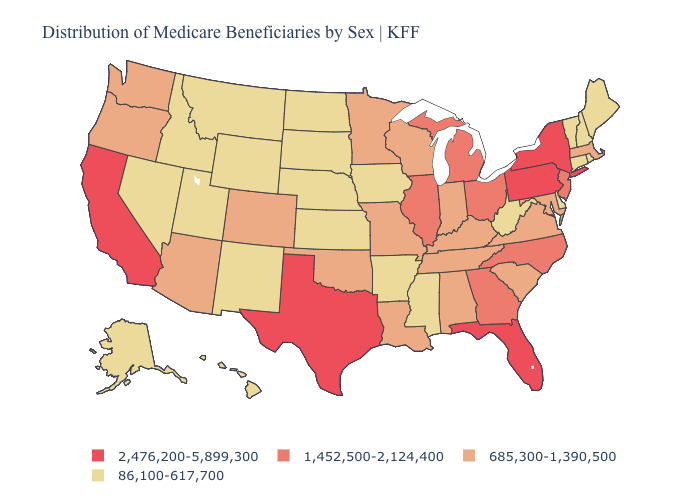Which states hav the highest value in the Northeast?
Concise answer only. New York, Pennsylvania. What is the value of Michigan?
Be succinct. 1,452,500-2,124,400. What is the highest value in the USA?
Answer briefly. 2,476,200-5,899,300. Does Hawaii have the lowest value in the USA?
Quick response, please. Yes. Among the states that border Louisiana , does Arkansas have the highest value?
Write a very short answer. No. Name the states that have a value in the range 1,452,500-2,124,400?
Keep it brief. Georgia, Illinois, Michigan, New Jersey, North Carolina, Ohio. Does New York have the highest value in the USA?
Short answer required. Yes. Name the states that have a value in the range 2,476,200-5,899,300?
Quick response, please. California, Florida, New York, Pennsylvania, Texas. Does the map have missing data?
Write a very short answer. No. What is the value of Rhode Island?
Give a very brief answer. 86,100-617,700. Which states have the lowest value in the MidWest?
Answer briefly. Iowa, Kansas, Nebraska, North Dakota, South Dakota. Does Tennessee have a higher value than Massachusetts?
Keep it brief. No. Name the states that have a value in the range 2,476,200-5,899,300?
Short answer required. California, Florida, New York, Pennsylvania, Texas. What is the highest value in the West ?
Keep it brief. 2,476,200-5,899,300. What is the highest value in the USA?
Give a very brief answer. 2,476,200-5,899,300. 